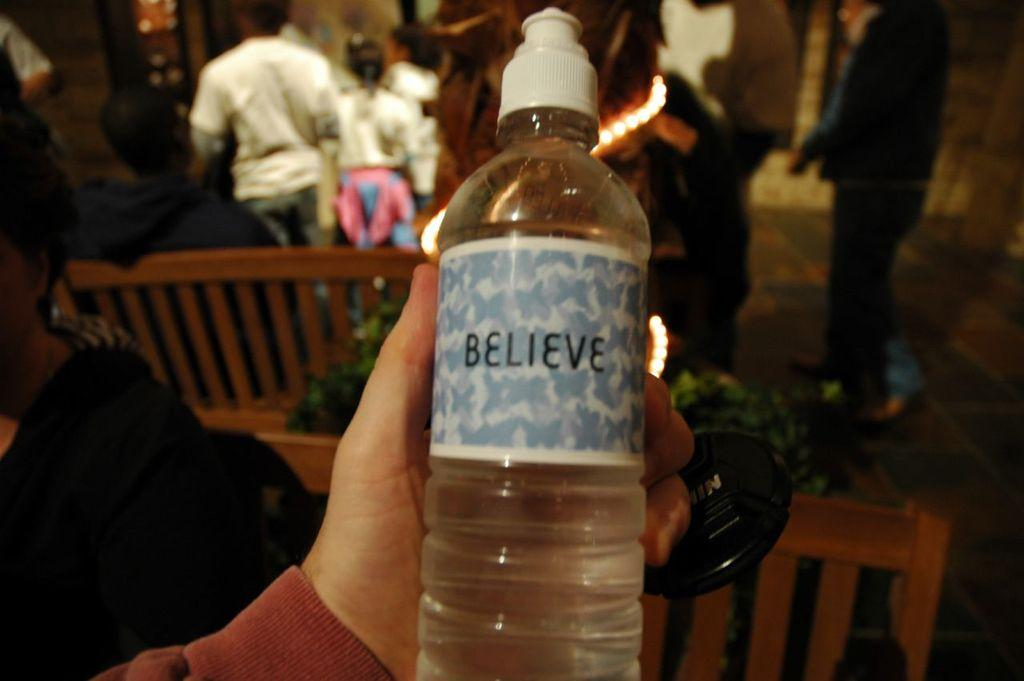What is the human hand holding in the image? The human hand is holding a bottle in the image. What type of structure can be seen in the image? There is a wooden fence in the image. Can you describe the group of people in the image? There is a crowd in the image. How many children are playing with the chicken in the image? There are no children or chicken present in the image. 